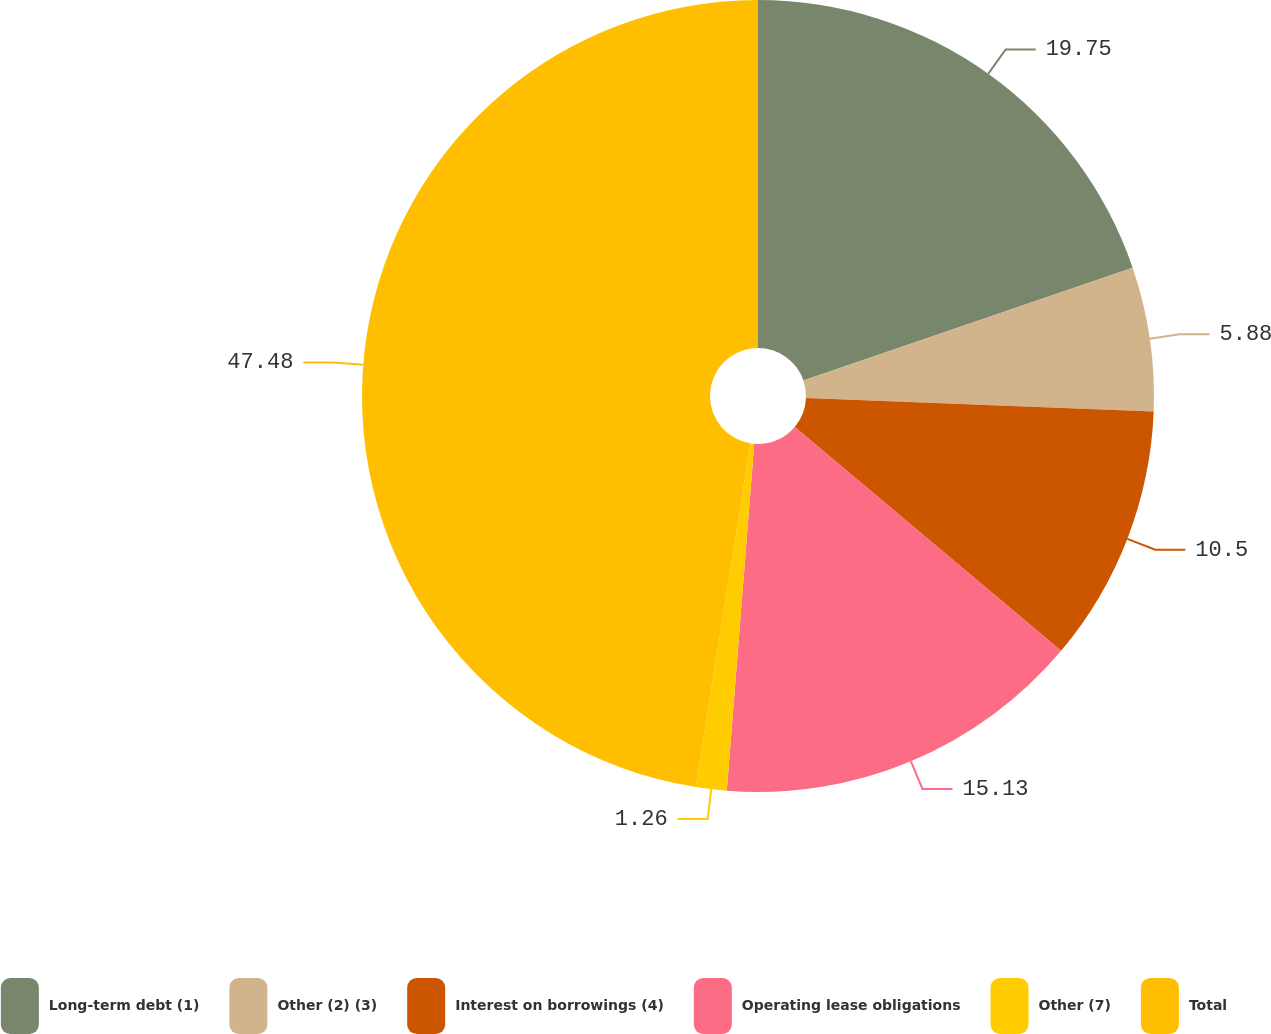Convert chart. <chart><loc_0><loc_0><loc_500><loc_500><pie_chart><fcel>Long-term debt (1)<fcel>Other (2) (3)<fcel>Interest on borrowings (4)<fcel>Operating lease obligations<fcel>Other (7)<fcel>Total<nl><fcel>19.75%<fcel>5.88%<fcel>10.5%<fcel>15.13%<fcel>1.26%<fcel>47.49%<nl></chart> 